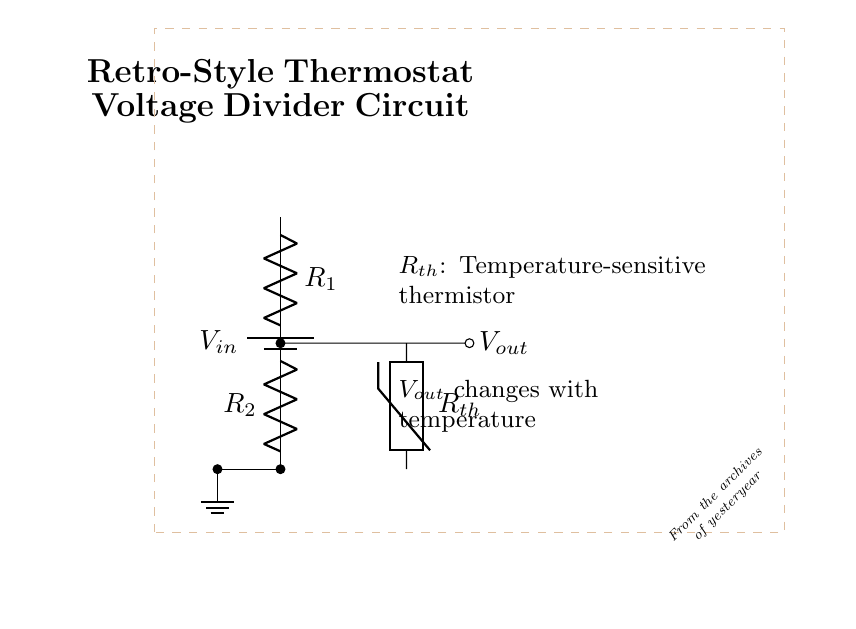What is the input voltage in this circuit? The input voltage is labeled as V_in, which is indicated by the battery symbol at the top of the circuit diagram.
Answer: V_in What are the values of the resistors in this voltage divider? The resistors are labeled R_1 and R_2, but their specific values are not shown in the diagram. Only their labels indicate their presence in the voltage divider configuration.
Answer: R_1 and R_2 What component changes resistance with temperature? The thermistor, labeled as R_th, is a temperature-sensitive component that varies resistance based on the temperature.
Answer: R_th What happens to V_out when the temperature rises? As the temperature rises, the resistance of the thermistor decreases, which in turn causes the output voltage V_out to change, likely increasing as R_th drops in a typical setup.
Answer: V_out increases What type of circuit is illustrated? The circuit is a voltage divider, which is specifically designed to take an input voltage and produce a lower output voltage that is a fraction of the input, based on the resistances used.
Answer: Voltage divider What does the dashed rectangle represent in the diagram? The dashed rectangle represents a vintage newspaper effect, providing a stylistic presentation, indicating that the information may be from older sources or archives.
Answer: Vintage newspaper effect 